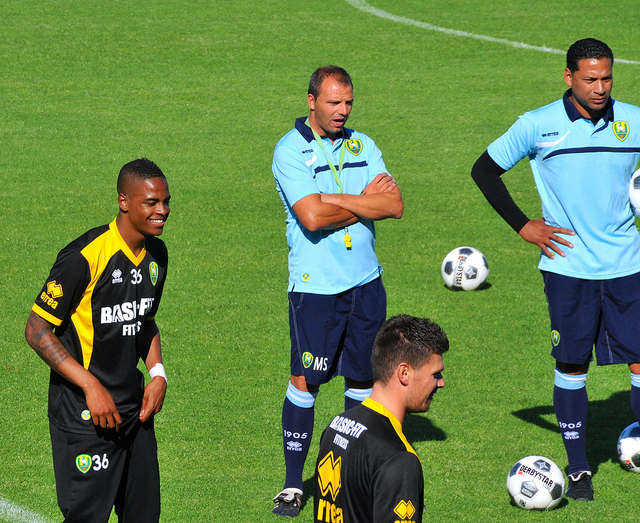Please extract the text content from this image. BASI-F FIT 36 BASIC FIT 1905 MS OERBYSTAAR 